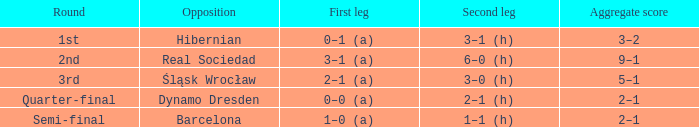What was the score in the first leg match against real sociedad? 3–1 (a). 